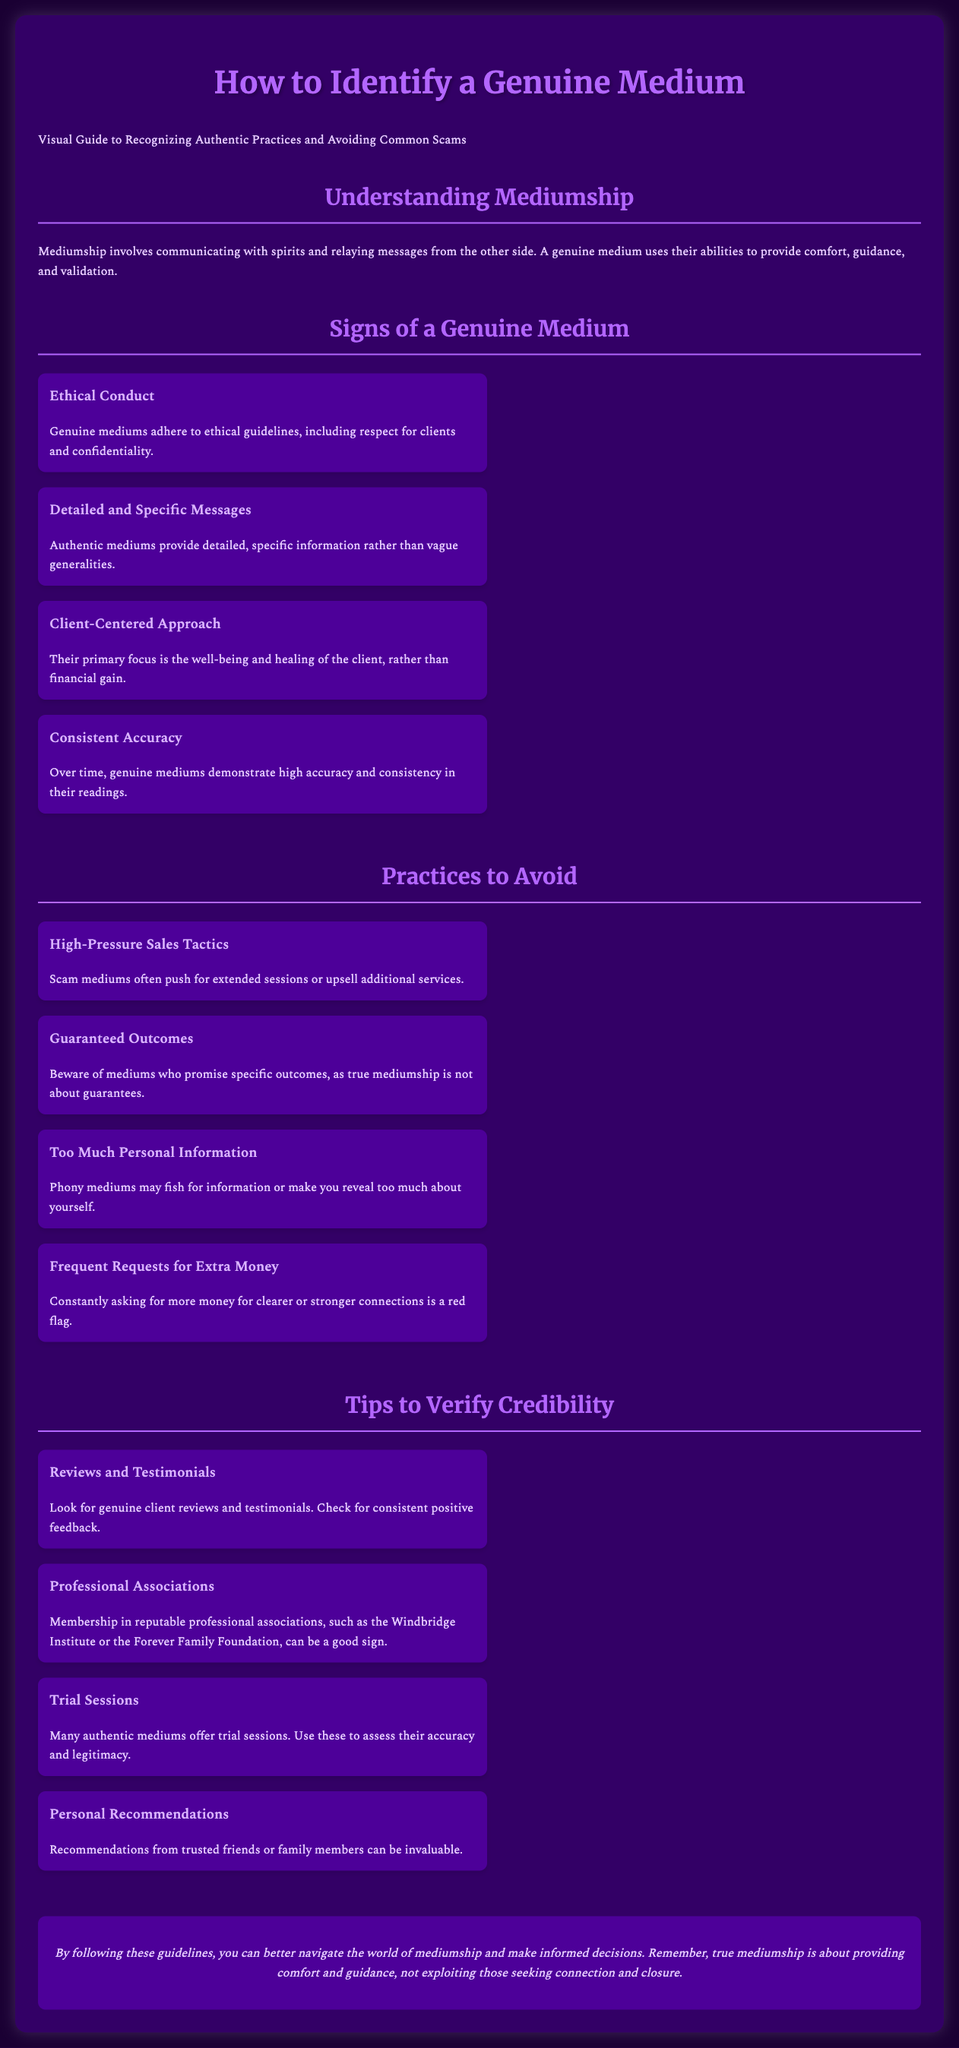what is a genuine medium? A genuine medium uses their abilities to provide comfort, guidance, and validation.
Answer: comfort, guidance, validation what are the ethical guidelines genuine mediums adhere to? Genuine mediums adhere to ethical guidelines, including respect for clients and confidentiality.
Answer: respect for clients, confidentiality what should you look for in client reviews? Look for genuine client reviews and testimonials. Check for consistent positive feedback.
Answer: consistent positive feedback what is a common tactic used by scam mediums? Scam mediums often push for extended sessions or upsell additional services.
Answer: high-pressure sales tactics which associations can indicate a medium's credibility? Membership in reputable professional associations can be a good sign.
Answer: professional associations how many practices should you avoid according to the document? The document lists four practices to avoid.
Answer: four what type of approach do genuine mediums have? Their primary focus is the well-being and healing of the client.
Answer: client-centered approach what is a trial session offered by authentic mediums? Many authentic mediums offer trial sessions to assess their accuracy and legitimacy.
Answer: trial sessions what is the overall aim of true mediumship? True mediumship is about providing comfort and guidance, not exploiting those seeking connection and closure.
Answer: comfort and guidance 